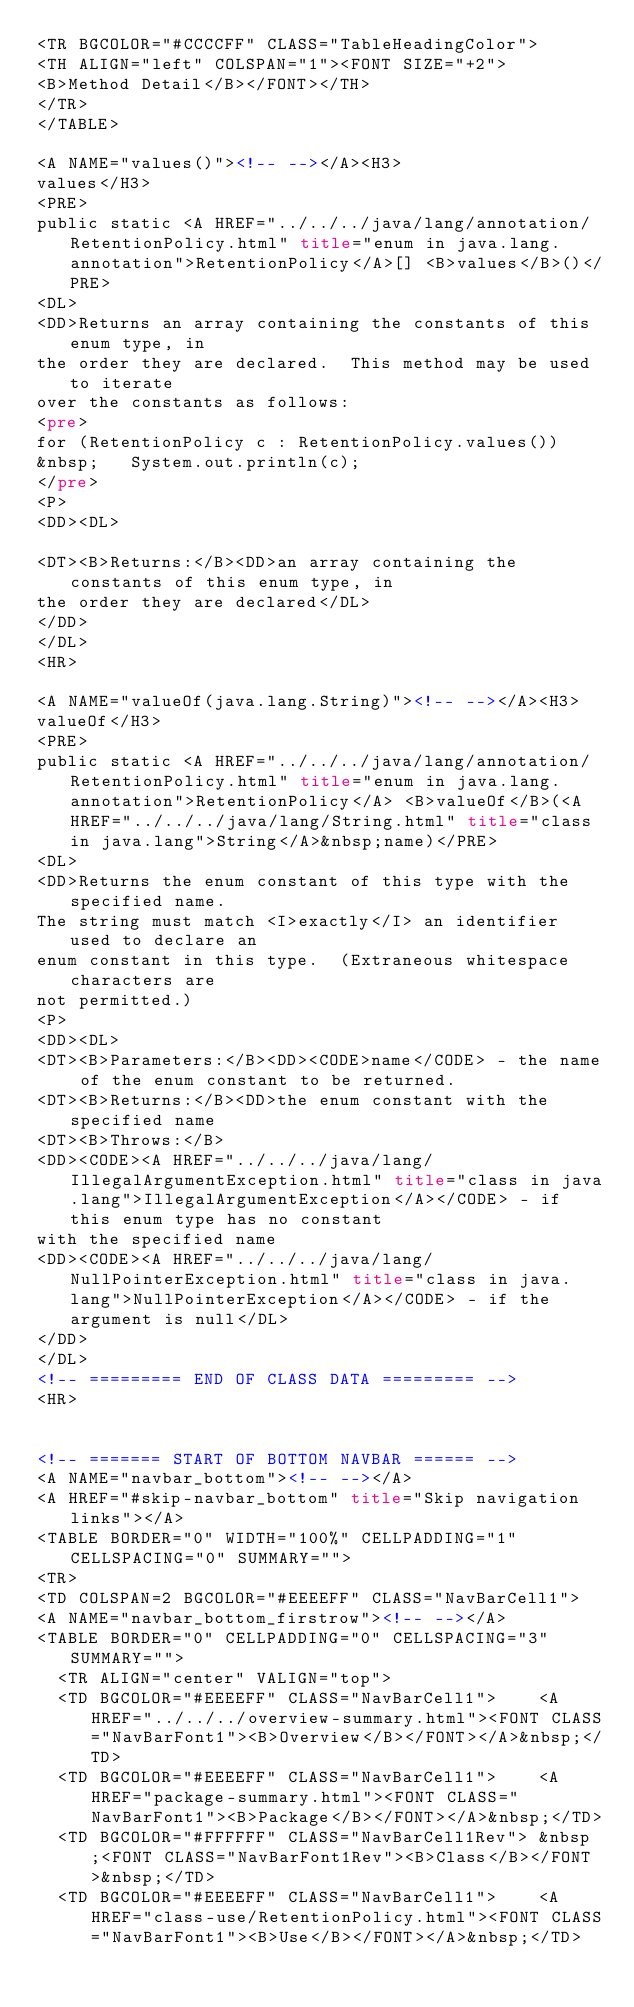<code> <loc_0><loc_0><loc_500><loc_500><_HTML_><TR BGCOLOR="#CCCCFF" CLASS="TableHeadingColor">
<TH ALIGN="left" COLSPAN="1"><FONT SIZE="+2">
<B>Method Detail</B></FONT></TH>
</TR>
</TABLE>

<A NAME="values()"><!-- --></A><H3>
values</H3>
<PRE>
public static <A HREF="../../../java/lang/annotation/RetentionPolicy.html" title="enum in java.lang.annotation">RetentionPolicy</A>[] <B>values</B>()</PRE>
<DL>
<DD>Returns an array containing the constants of this enum type, in
the order they are declared.  This method may be used to iterate
over the constants as follows:
<pre>
for (RetentionPolicy c : RetentionPolicy.values())
&nbsp;   System.out.println(c);
</pre>
<P>
<DD><DL>

<DT><B>Returns:</B><DD>an array containing the constants of this enum type, in
the order they are declared</DL>
</DD>
</DL>
<HR>

<A NAME="valueOf(java.lang.String)"><!-- --></A><H3>
valueOf</H3>
<PRE>
public static <A HREF="../../../java/lang/annotation/RetentionPolicy.html" title="enum in java.lang.annotation">RetentionPolicy</A> <B>valueOf</B>(<A HREF="../../../java/lang/String.html" title="class in java.lang">String</A>&nbsp;name)</PRE>
<DL>
<DD>Returns the enum constant of this type with the specified name.
The string must match <I>exactly</I> an identifier used to declare an
enum constant in this type.  (Extraneous whitespace characters are 
not permitted.)
<P>
<DD><DL>
<DT><B>Parameters:</B><DD><CODE>name</CODE> - the name of the enum constant to be returned.
<DT><B>Returns:</B><DD>the enum constant with the specified name
<DT><B>Throws:</B>
<DD><CODE><A HREF="../../../java/lang/IllegalArgumentException.html" title="class in java.lang">IllegalArgumentException</A></CODE> - if this enum type has no constant
with the specified name
<DD><CODE><A HREF="../../../java/lang/NullPointerException.html" title="class in java.lang">NullPointerException</A></CODE> - if the argument is null</DL>
</DD>
</DL>
<!-- ========= END OF CLASS DATA ========= -->
<HR>


<!-- ======= START OF BOTTOM NAVBAR ====== -->
<A NAME="navbar_bottom"><!-- --></A>
<A HREF="#skip-navbar_bottom" title="Skip navigation links"></A>
<TABLE BORDER="0" WIDTH="100%" CELLPADDING="1" CELLSPACING="0" SUMMARY="">
<TR>
<TD COLSPAN=2 BGCOLOR="#EEEEFF" CLASS="NavBarCell1">
<A NAME="navbar_bottom_firstrow"><!-- --></A>
<TABLE BORDER="0" CELLPADDING="0" CELLSPACING="3" SUMMARY="">
  <TR ALIGN="center" VALIGN="top">
  <TD BGCOLOR="#EEEEFF" CLASS="NavBarCell1">    <A HREF="../../../overview-summary.html"><FONT CLASS="NavBarFont1"><B>Overview</B></FONT></A>&nbsp;</TD>
  <TD BGCOLOR="#EEEEFF" CLASS="NavBarCell1">    <A HREF="package-summary.html"><FONT CLASS="NavBarFont1"><B>Package</B></FONT></A>&nbsp;</TD>
  <TD BGCOLOR="#FFFFFF" CLASS="NavBarCell1Rev"> &nbsp;<FONT CLASS="NavBarFont1Rev"><B>Class</B></FONT>&nbsp;</TD>
  <TD BGCOLOR="#EEEEFF" CLASS="NavBarCell1">    <A HREF="class-use/RetentionPolicy.html"><FONT CLASS="NavBarFont1"><B>Use</B></FONT></A>&nbsp;</TD></code> 